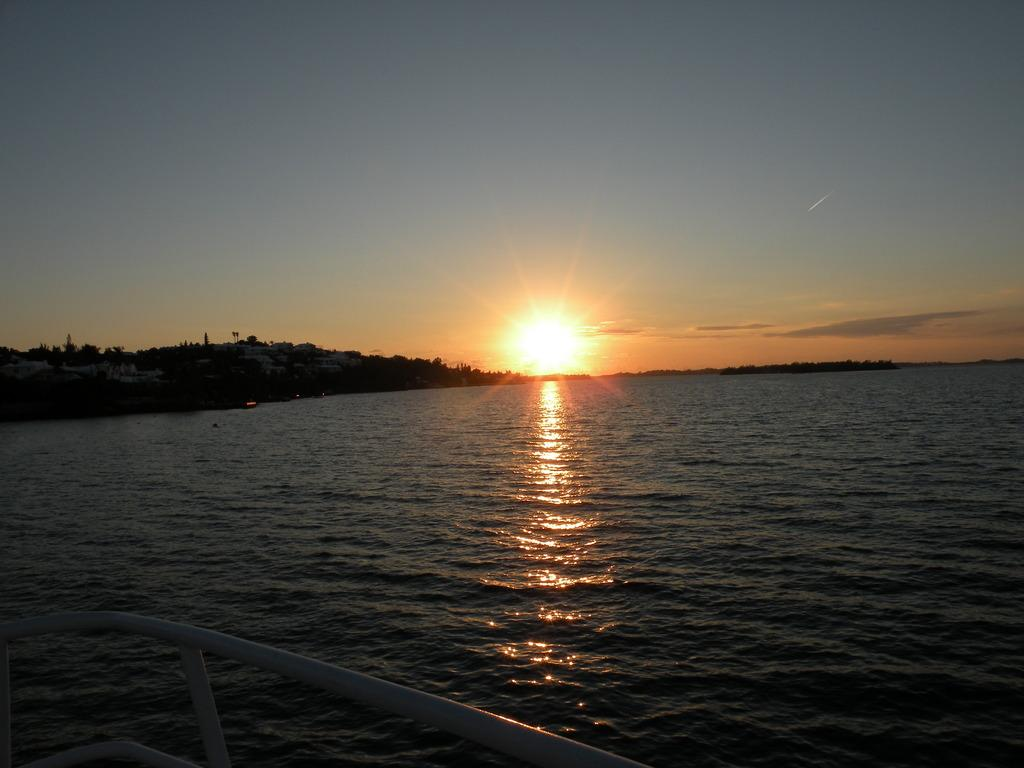What can be seen in the distance in the image? There is a sunset in the distance. What is visible in the image besides the sunset? There is water visible in the image. What stage of learning is the cent experiencing in the image? There is no mention of a cent or any learning process in the image; it features a sunset and water. 